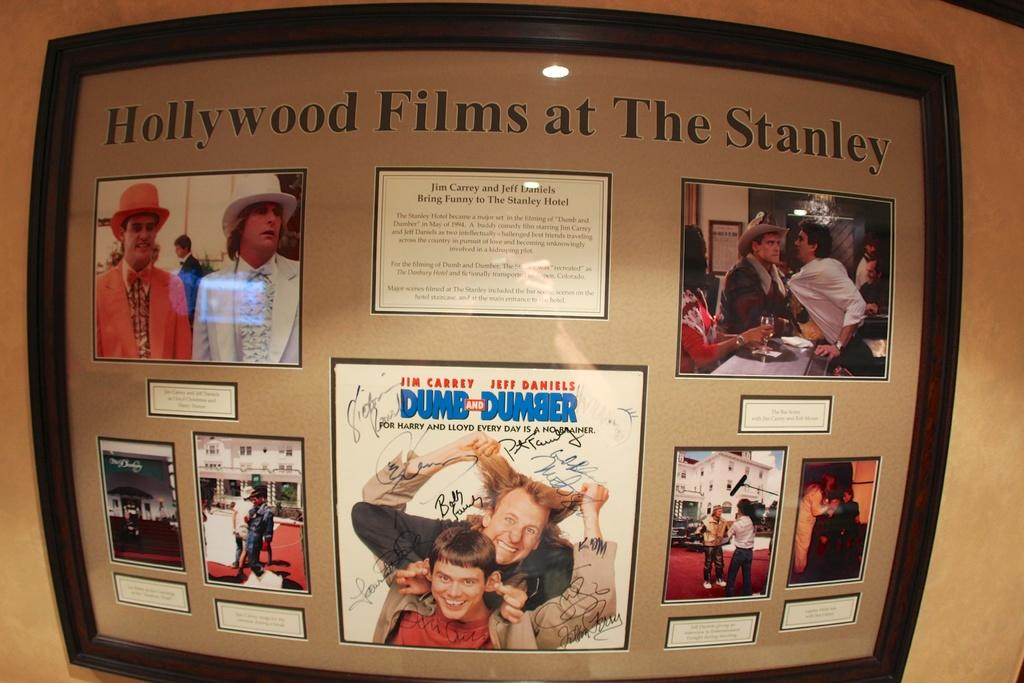<image>
Describe the image concisely. display of hollywood films at the stanley that has scenes from movie dumb and dumber 